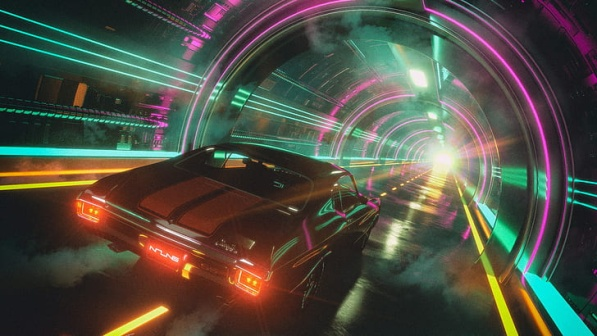What do you think is the destination of the car? Given the intense forward motion and the white light at the tunnel's end, the car seems to be headed towards a significant yet unknown destination, possibly a metaphor for moving towards future opportunities or escaping from the past. This journey could be emblematic of progress or adventure in this neon-soaked futuristic setting. 